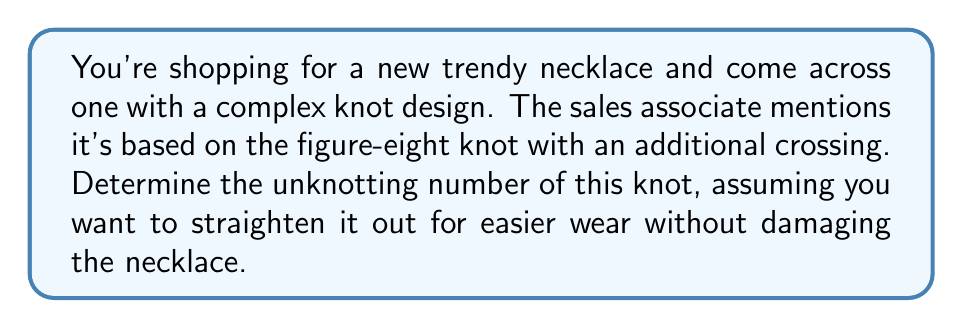Provide a solution to this math problem. Let's approach this step-by-step:

1) The figure-eight knot is a well-known knot with unknotting number 1. It has 4 crossings in its minimal diagram.

2) The necklace has an additional crossing, so we're dealing with a knot that has 5 crossings in total.

3) To calculate the unknotting number, we need to determine the minimum number of crossing changes required to transform this knot into the unknot (trivial knot).

4) For a knot with 5 crossings, the maximum possible unknotting number is 2. This is because changing 2 crossings can unknot any 5-crossing knot.

5) However, since this knot is based on the figure-eight knot (which has unknotting number 1), we can deduce that changing the additional crossing will likely be sufficient to unknot it.

6) Mathematically, we can express this as:

   $$u(K) \leq u(K') + 1$$

   Where $u(K)$ is the unknotting number of our necklace knot, $u(K')$ is the unknotting number of the figure-eight knot (which is 1), and 1 represents the additional crossing.

7) Therefore, the unknotting number of this knot is most likely 2.

This means you would need to "undo" at most 2 crossings to straighten out the necklace for easier wear.
Answer: 2 